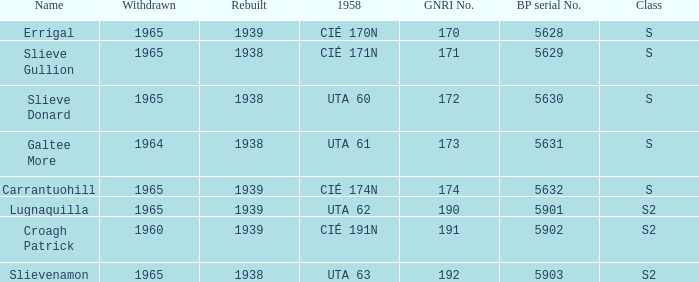What is the smallest withdrawn value with a GNRI greater than 172, name of Croagh Patrick and was rebuilt before 1939? None. 